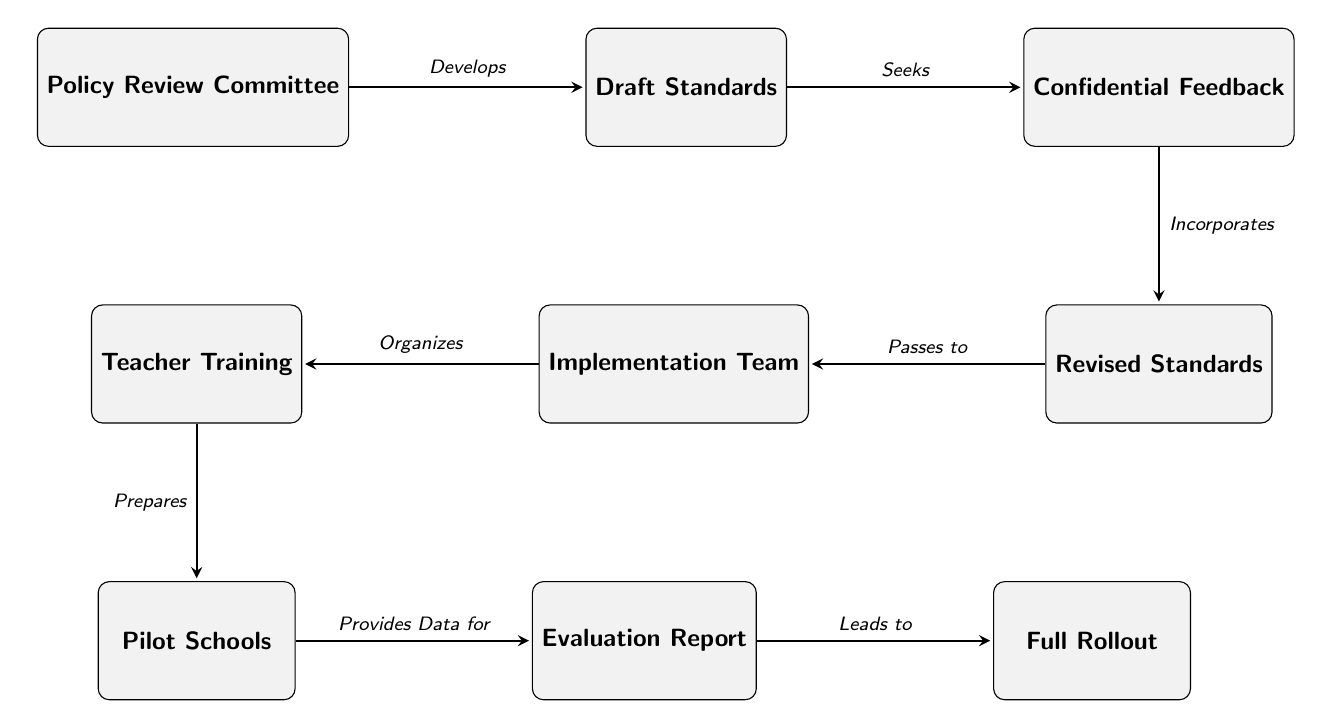What is the first node in the diagram? The first node is "Policy Review Committee", which is the starting point of the flow represented in the diagram.
Answer: Policy Review Committee How many nodes are in the diagram? By counting each unique element in the diagram, there are a total of nine nodes listed sequentially from "Policy Review Committee" to "Full Rollout".
Answer: 9 What action does the "Draft Standards" node seek? The action that the "Draft Standards" node seeks is "Confidential Feedback", as indicated by the directed edge pointing towards this node from "Draft Standards".
Answer: Confidential Feedback Which node provides data for the "Evaluation Report"? The node that provides data for the "Evaluation Report" is "Pilot Schools", as it is connected with a directed edge leading to the "Evaluation Report" node.
Answer: Pilot Schools What precedes the "Full Rollout" in the diagram? The node that precedes the "Full Rollout" is "Evaluation Report", as it is the last step before reaching the eventual rollout phase in the sequence.
Answer: Evaluation Report What does the "Implementation Team" organize? The "Implementation Team" organizes "Teacher Training", which is indicated by the directed edge linking these two nodes.
Answer: Teacher Training Which node incorporates confidential feedback? The node that incorporates confidential feedback is "Revised Standards", as shown by the directed edge that connects "Confidential Feedback" to "Revised Standards".
Answer: Revised Standards What leads to the "Full Rollout"? The action that leads to the "Full Rollout" is the "Evaluation Report", as it directly flows into the final node in the sequence.
Answer: Evaluation Report What is the final node in the diagram? The final node in the diagram is "Full Rollout", which signifies the completion of the process outlined in the diagram.
Answer: Full Rollout 